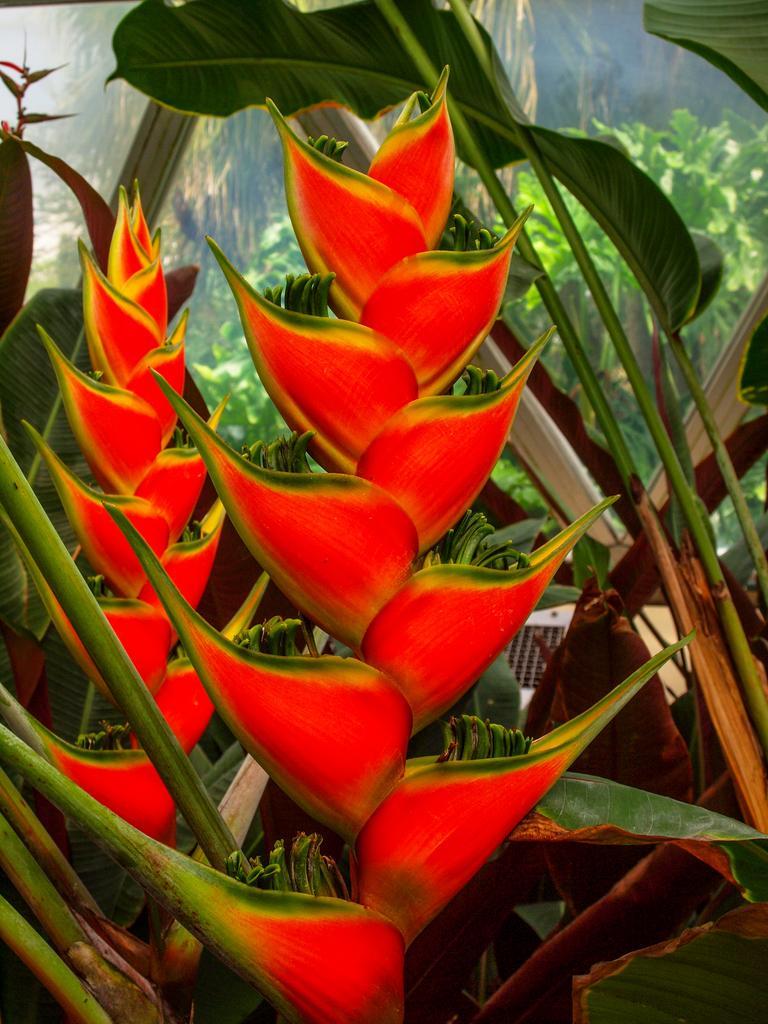Could you give a brief overview of what you see in this image? In this image we can see there is a red color steps flower beside that there are so many plants. 